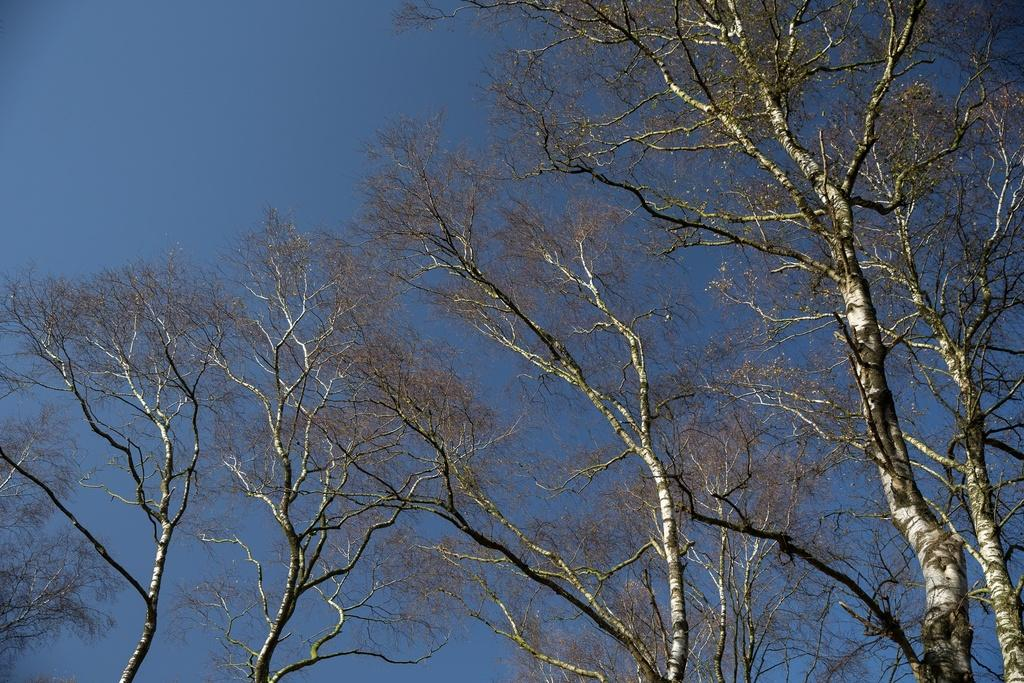What type of vegetation is present in the image? There are trees with branches in the image. What part of the natural environment is visible in the image? The sky is visible in the image. What is the color of the sky in the image? The color of the sky is blue. Where is the letter being written on the stage in the image? There is no letter or stage present in the image; it only features trees and the blue sky. 